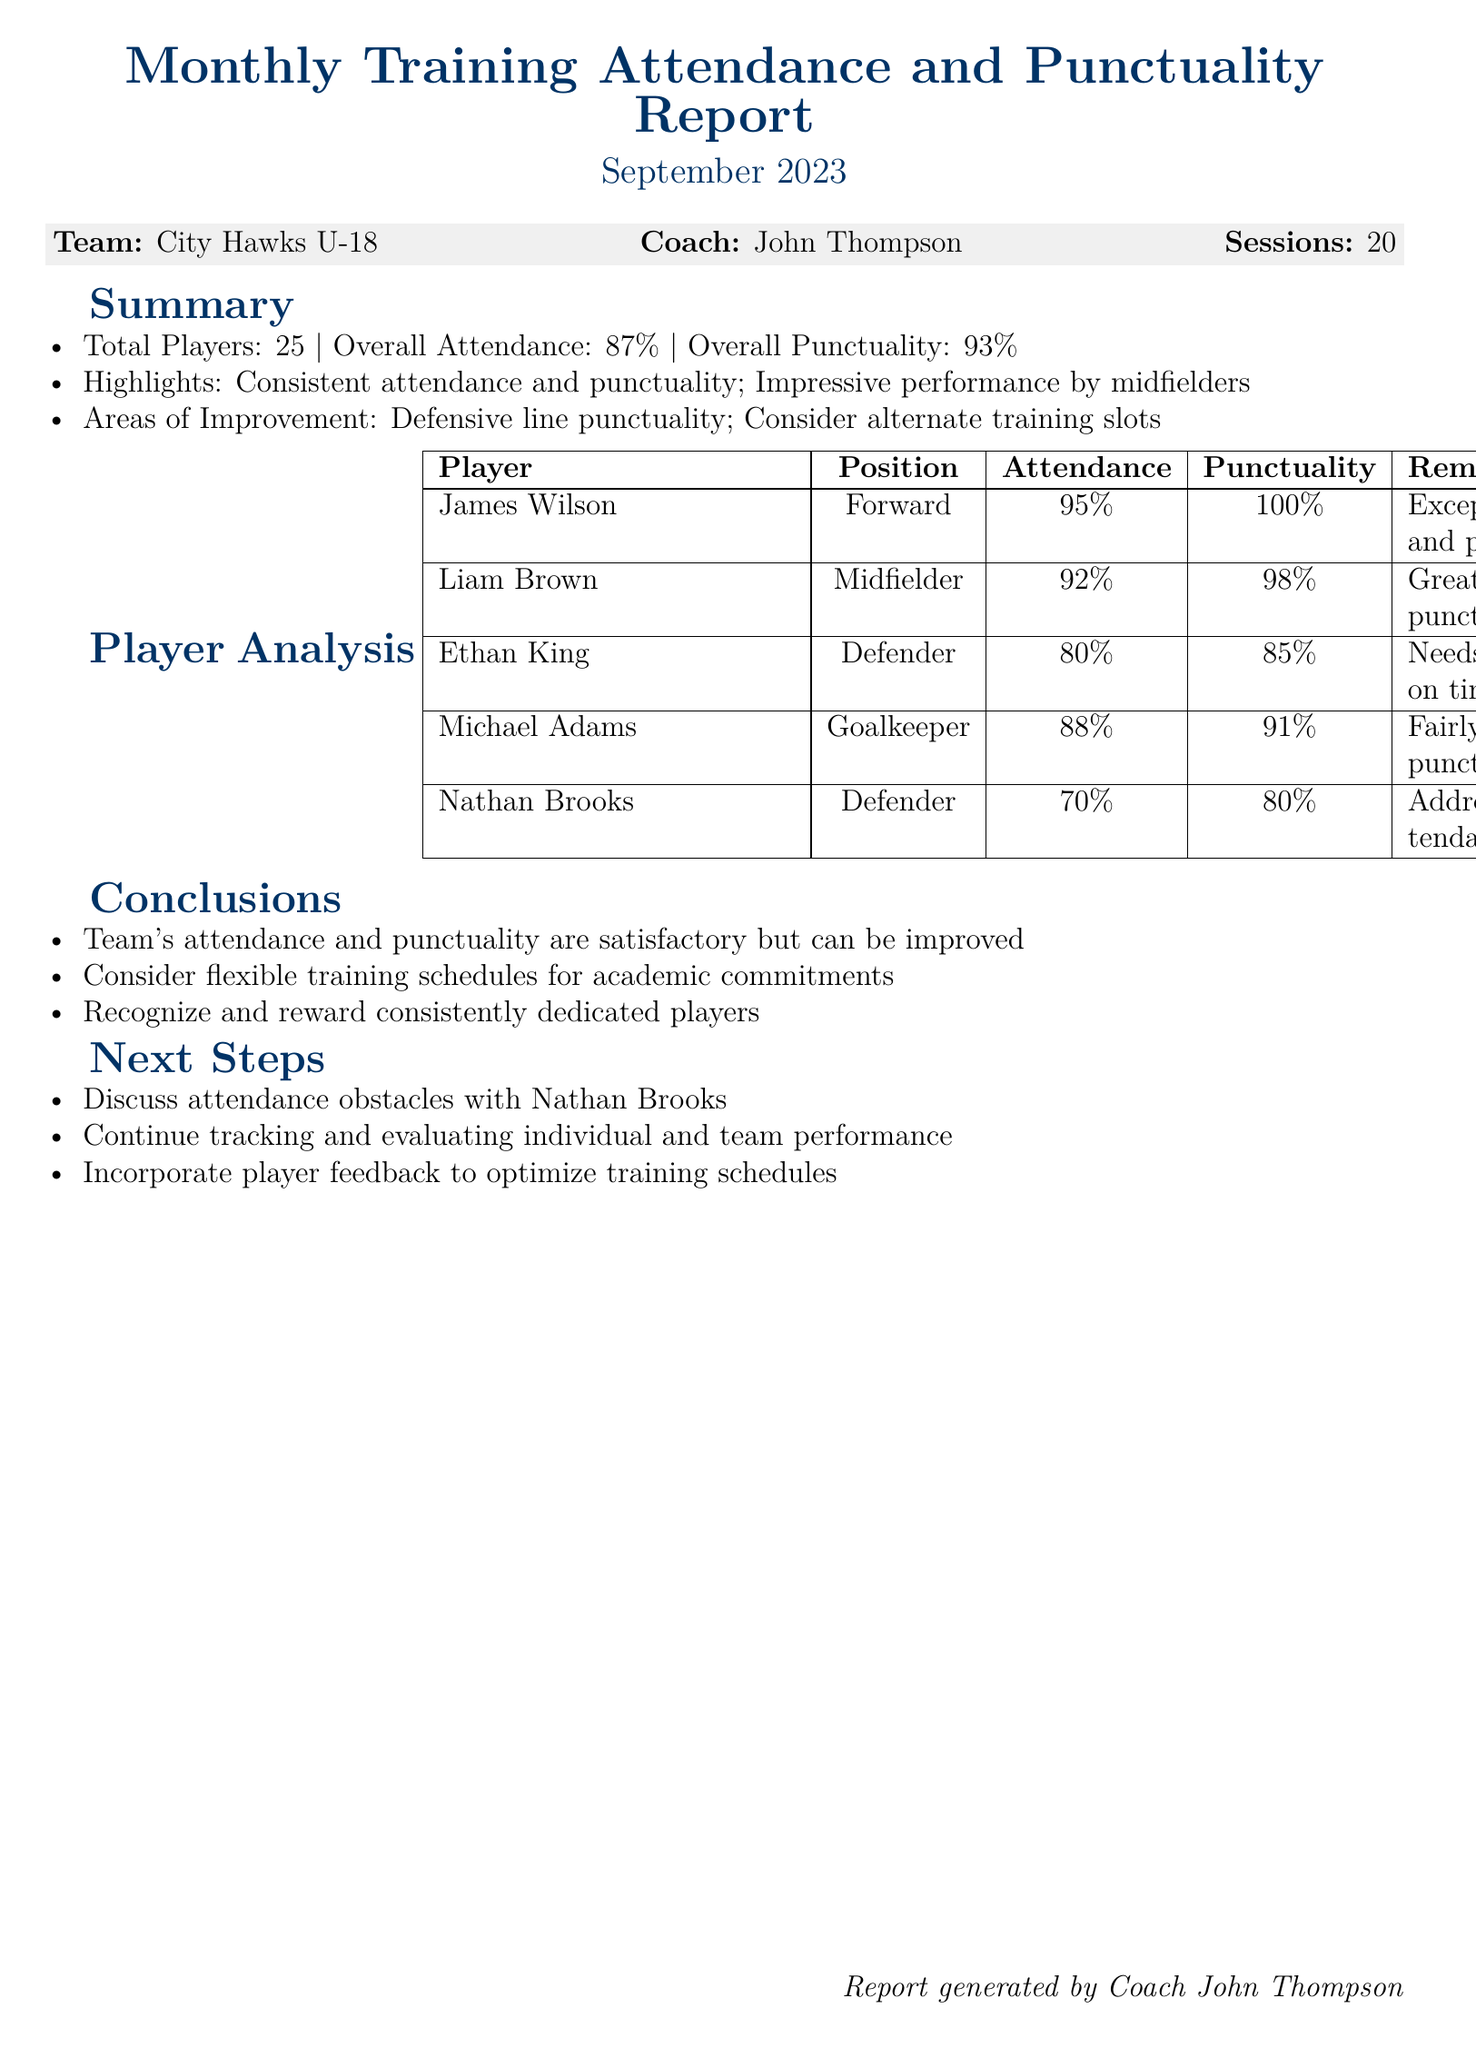What is the total number of players? The total number of players is provided in the summary section of the document.
Answer: 25 What was the overall attendance percentage? The overall attendance percentage is mentioned in the summary section.
Answer: 87% Who is the coach of the team? The name of the coach is listed under the team information.
Answer: John Thompson What position does Ethan King play? The position of Ethan King is indicated in the player analysis table.
Answer: Defender What is the punctuality percentage of James Wilson? James Wilson's punctuality percentage is specified in the player analysis table.
Answer: 100% What area needs improvement according to the highlights? The area that needs improvement is mentioned in the summary section of the report.
Answer: Defensive line punctuality How many sessions were conducted in September 2023? The number of sessions is noted in the team information at the beginning of the document.
Answer: 20 What is the attendance percentage of Nathan Brooks? Nathan Brooks's attendance percentage is included in the player analysis table.
Answer: 70% What recommendation is made for Nathan Brooks? The recommendation for Nathan Brooks is in the next steps section of the document.
Answer: Discuss attendance obstacles 